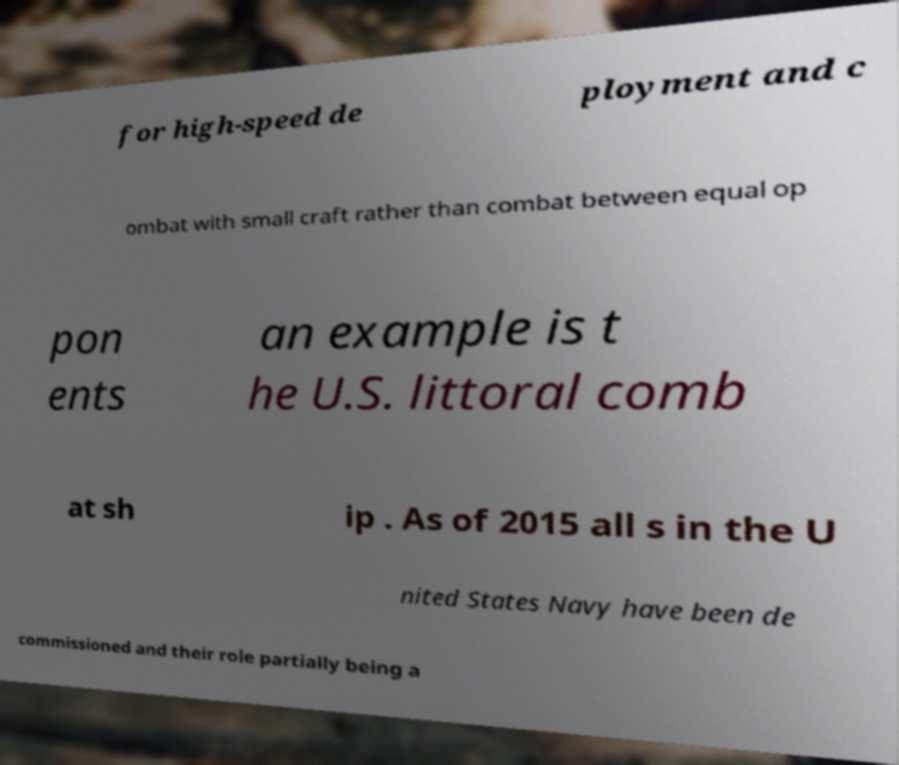Could you extract and type out the text from this image? for high-speed de ployment and c ombat with small craft rather than combat between equal op pon ents an example is t he U.S. littoral comb at sh ip . As of 2015 all s in the U nited States Navy have been de commissioned and their role partially being a 